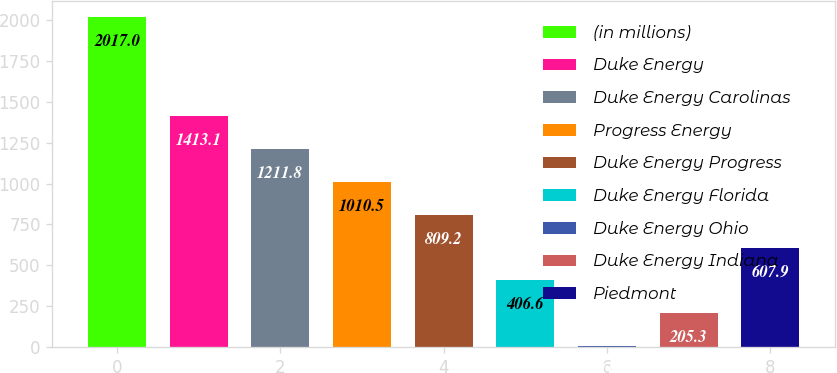<chart> <loc_0><loc_0><loc_500><loc_500><bar_chart><fcel>(in millions)<fcel>Duke Energy<fcel>Duke Energy Carolinas<fcel>Progress Energy<fcel>Duke Energy Progress<fcel>Duke Energy Florida<fcel>Duke Energy Ohio<fcel>Duke Energy Indiana<fcel>Piedmont<nl><fcel>2017<fcel>1413.1<fcel>1211.8<fcel>1010.5<fcel>809.2<fcel>406.6<fcel>4<fcel>205.3<fcel>607.9<nl></chart> 